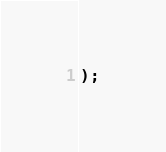Convert code to text. <code><loc_0><loc_0><loc_500><loc_500><_SQL_>);
</code> 